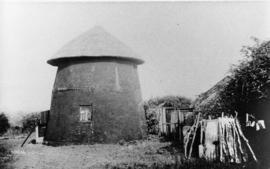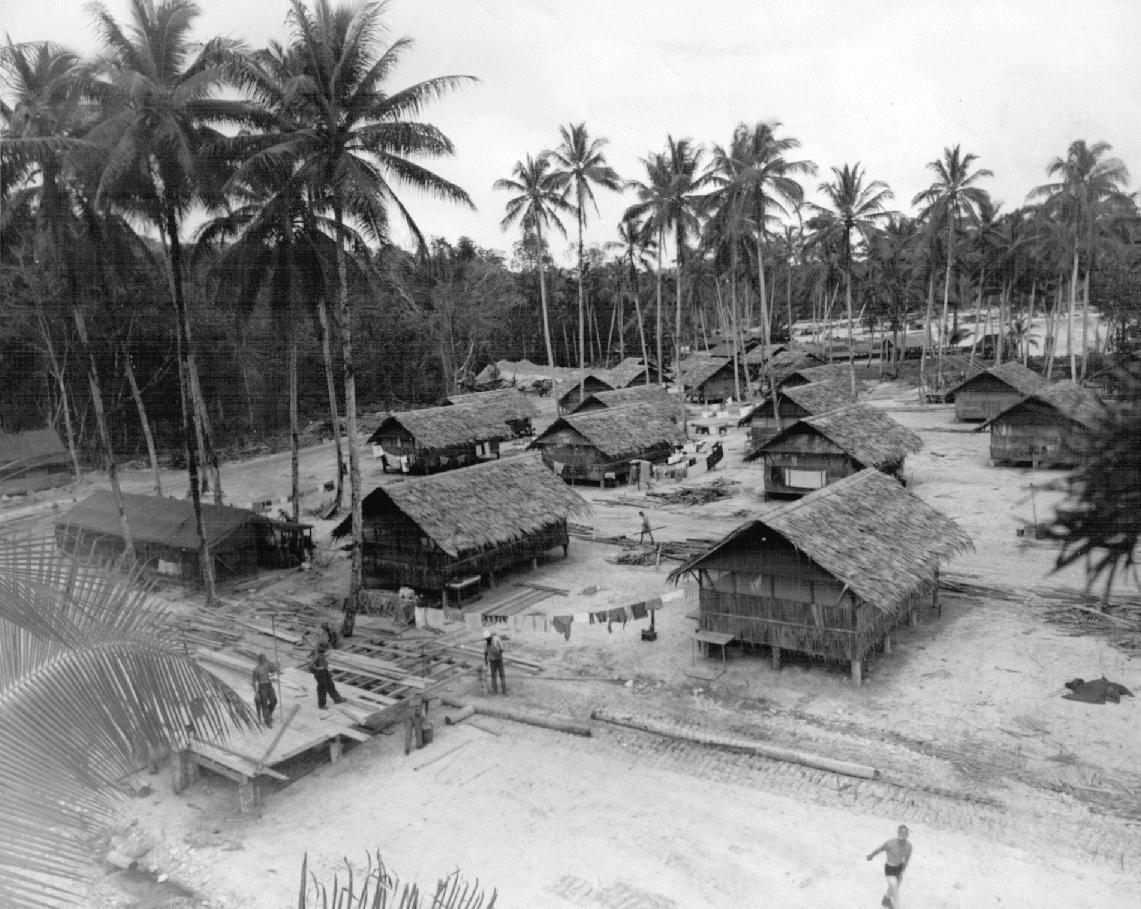The first image is the image on the left, the second image is the image on the right. Examine the images to the left and right. Is the description "Two houses have chimneys." accurate? Answer yes or no. No. The first image is the image on the left, the second image is the image on the right. For the images displayed, is the sentence "The right image features palm trees behind at least one primitive structure with a peaked thatch roof." factually correct? Answer yes or no. Yes. 